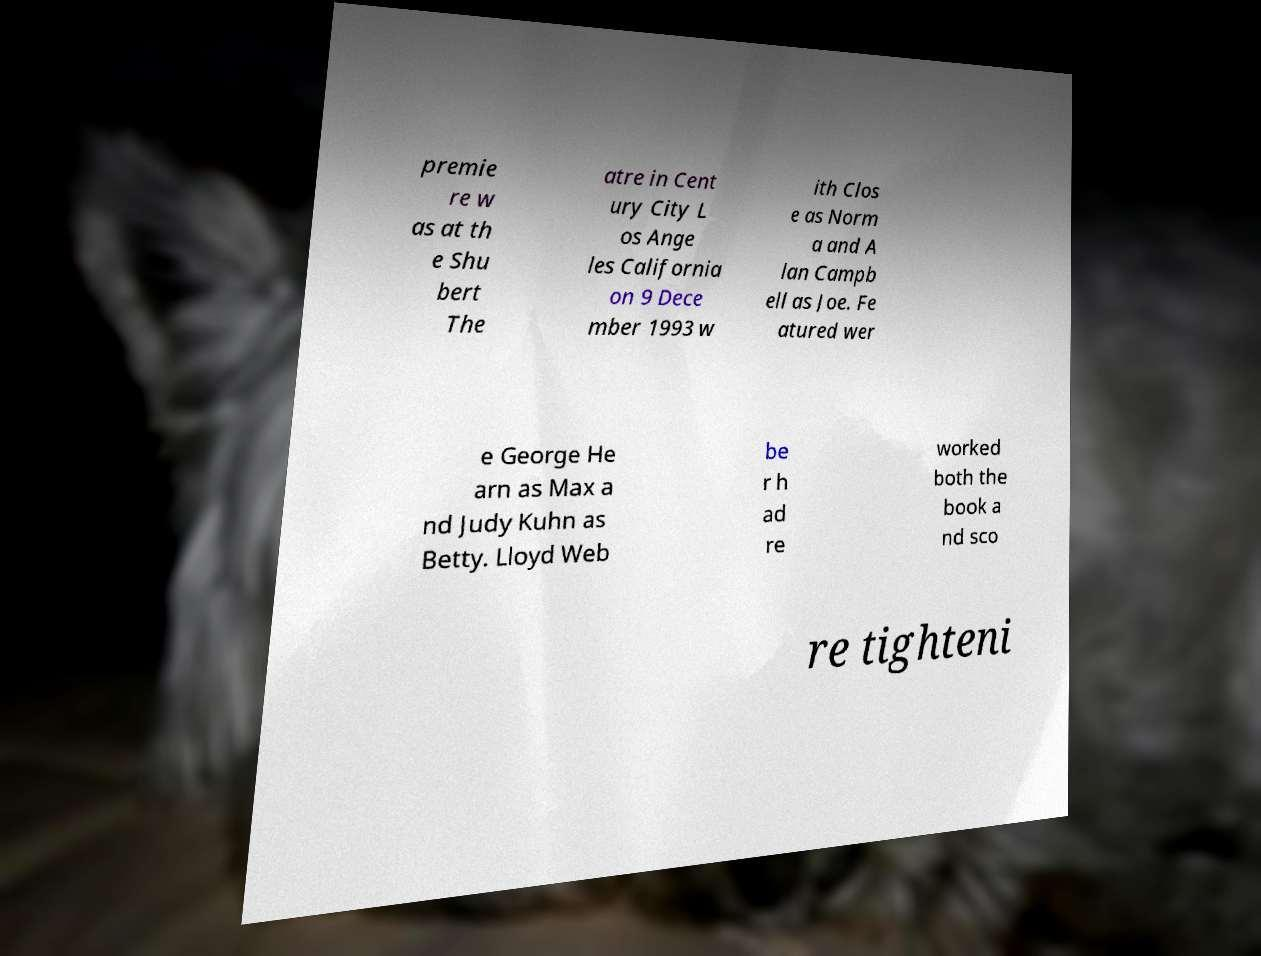Could you extract and type out the text from this image? premie re w as at th e Shu bert The atre in Cent ury City L os Ange les California on 9 Dece mber 1993 w ith Clos e as Norm a and A lan Campb ell as Joe. Fe atured wer e George He arn as Max a nd Judy Kuhn as Betty. Lloyd Web be r h ad re worked both the book a nd sco re tighteni 